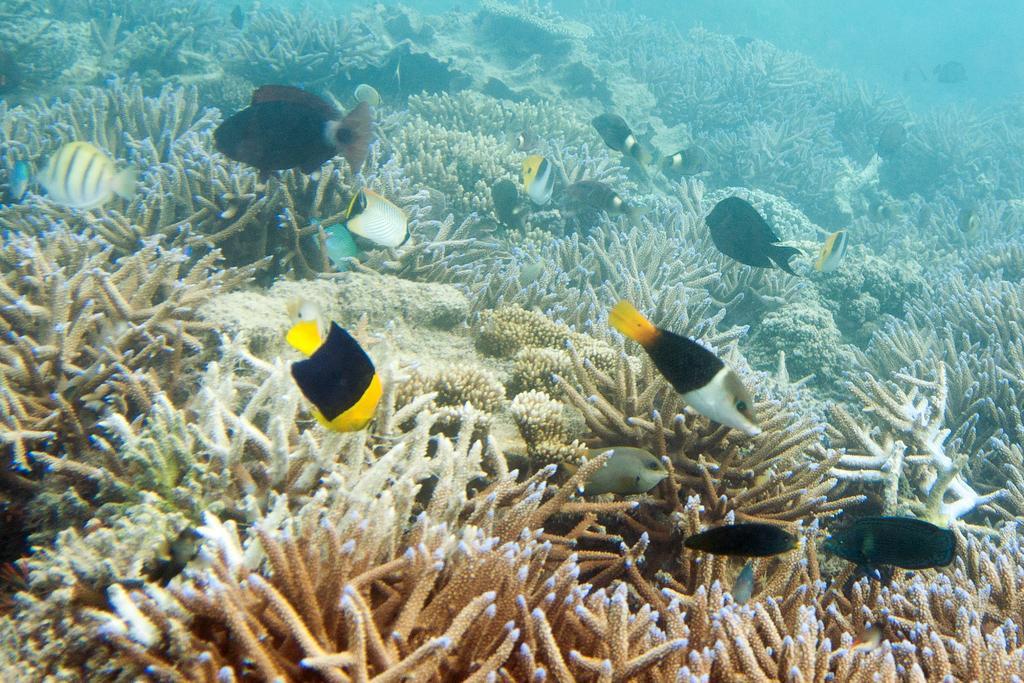Could you give a brief overview of what you see in this image? This picture describes about under water environment, and also we can see few fishes. 